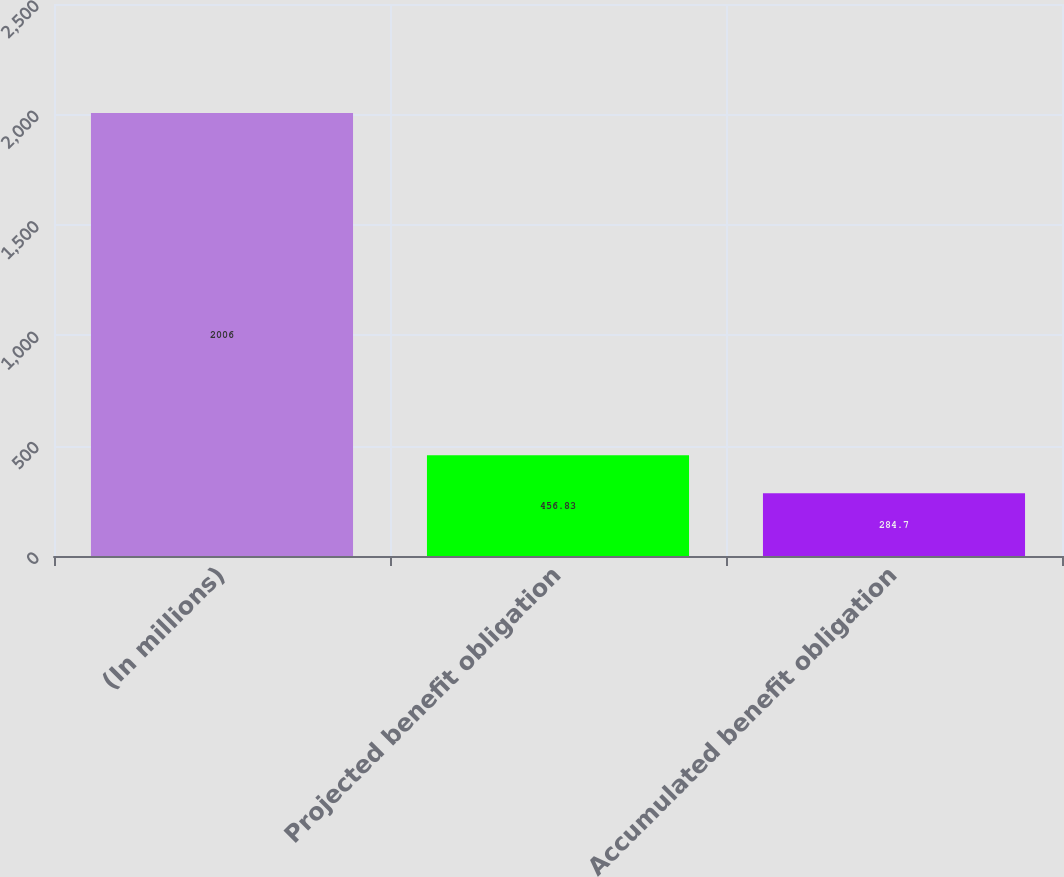Convert chart to OTSL. <chart><loc_0><loc_0><loc_500><loc_500><bar_chart><fcel>(In millions)<fcel>Projected benefit obligation<fcel>Accumulated benefit obligation<nl><fcel>2006<fcel>456.83<fcel>284.7<nl></chart> 